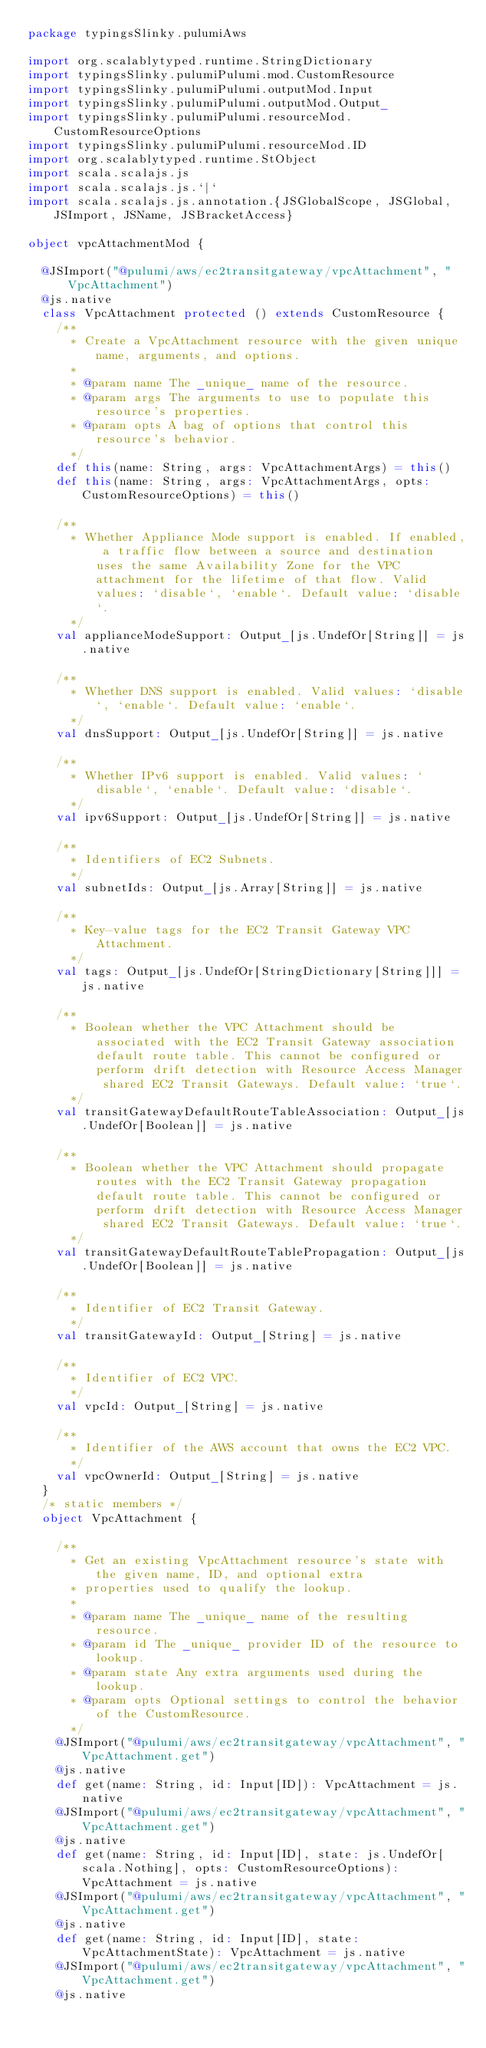<code> <loc_0><loc_0><loc_500><loc_500><_Scala_>package typingsSlinky.pulumiAws

import org.scalablytyped.runtime.StringDictionary
import typingsSlinky.pulumiPulumi.mod.CustomResource
import typingsSlinky.pulumiPulumi.outputMod.Input
import typingsSlinky.pulumiPulumi.outputMod.Output_
import typingsSlinky.pulumiPulumi.resourceMod.CustomResourceOptions
import typingsSlinky.pulumiPulumi.resourceMod.ID
import org.scalablytyped.runtime.StObject
import scala.scalajs.js
import scala.scalajs.js.`|`
import scala.scalajs.js.annotation.{JSGlobalScope, JSGlobal, JSImport, JSName, JSBracketAccess}

object vpcAttachmentMod {
  
  @JSImport("@pulumi/aws/ec2transitgateway/vpcAttachment", "VpcAttachment")
  @js.native
  class VpcAttachment protected () extends CustomResource {
    /**
      * Create a VpcAttachment resource with the given unique name, arguments, and options.
      *
      * @param name The _unique_ name of the resource.
      * @param args The arguments to use to populate this resource's properties.
      * @param opts A bag of options that control this resource's behavior.
      */
    def this(name: String, args: VpcAttachmentArgs) = this()
    def this(name: String, args: VpcAttachmentArgs, opts: CustomResourceOptions) = this()
    
    /**
      * Whether Appliance Mode support is enabled. If enabled, a traffic flow between a source and destination uses the same Availability Zone for the VPC attachment for the lifetime of that flow. Valid values: `disable`, `enable`. Default value: `disable`.
      */
    val applianceModeSupport: Output_[js.UndefOr[String]] = js.native
    
    /**
      * Whether DNS support is enabled. Valid values: `disable`, `enable`. Default value: `enable`.
      */
    val dnsSupport: Output_[js.UndefOr[String]] = js.native
    
    /**
      * Whether IPv6 support is enabled. Valid values: `disable`, `enable`. Default value: `disable`.
      */
    val ipv6Support: Output_[js.UndefOr[String]] = js.native
    
    /**
      * Identifiers of EC2 Subnets.
      */
    val subnetIds: Output_[js.Array[String]] = js.native
    
    /**
      * Key-value tags for the EC2 Transit Gateway VPC Attachment.
      */
    val tags: Output_[js.UndefOr[StringDictionary[String]]] = js.native
    
    /**
      * Boolean whether the VPC Attachment should be associated with the EC2 Transit Gateway association default route table. This cannot be configured or perform drift detection with Resource Access Manager shared EC2 Transit Gateways. Default value: `true`.
      */
    val transitGatewayDefaultRouteTableAssociation: Output_[js.UndefOr[Boolean]] = js.native
    
    /**
      * Boolean whether the VPC Attachment should propagate routes with the EC2 Transit Gateway propagation default route table. This cannot be configured or perform drift detection with Resource Access Manager shared EC2 Transit Gateways. Default value: `true`.
      */
    val transitGatewayDefaultRouteTablePropagation: Output_[js.UndefOr[Boolean]] = js.native
    
    /**
      * Identifier of EC2 Transit Gateway.
      */
    val transitGatewayId: Output_[String] = js.native
    
    /**
      * Identifier of EC2 VPC.
      */
    val vpcId: Output_[String] = js.native
    
    /**
      * Identifier of the AWS account that owns the EC2 VPC.
      */
    val vpcOwnerId: Output_[String] = js.native
  }
  /* static members */
  object VpcAttachment {
    
    /**
      * Get an existing VpcAttachment resource's state with the given name, ID, and optional extra
      * properties used to qualify the lookup.
      *
      * @param name The _unique_ name of the resulting resource.
      * @param id The _unique_ provider ID of the resource to lookup.
      * @param state Any extra arguments used during the lookup.
      * @param opts Optional settings to control the behavior of the CustomResource.
      */
    @JSImport("@pulumi/aws/ec2transitgateway/vpcAttachment", "VpcAttachment.get")
    @js.native
    def get(name: String, id: Input[ID]): VpcAttachment = js.native
    @JSImport("@pulumi/aws/ec2transitgateway/vpcAttachment", "VpcAttachment.get")
    @js.native
    def get(name: String, id: Input[ID], state: js.UndefOr[scala.Nothing], opts: CustomResourceOptions): VpcAttachment = js.native
    @JSImport("@pulumi/aws/ec2transitgateway/vpcAttachment", "VpcAttachment.get")
    @js.native
    def get(name: String, id: Input[ID], state: VpcAttachmentState): VpcAttachment = js.native
    @JSImport("@pulumi/aws/ec2transitgateway/vpcAttachment", "VpcAttachment.get")
    @js.native</code> 